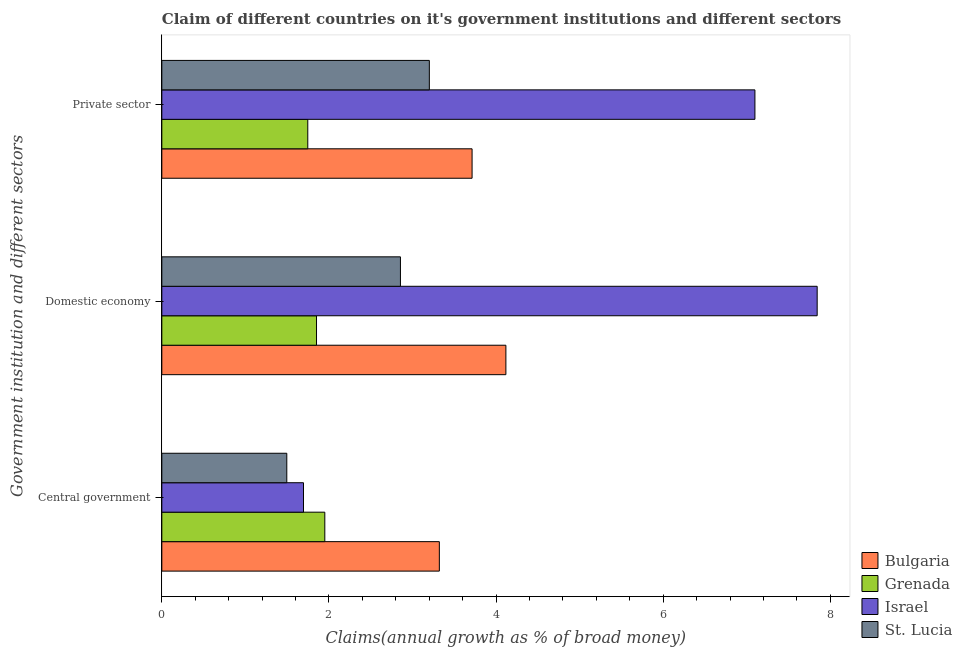How many groups of bars are there?
Give a very brief answer. 3. Are the number of bars per tick equal to the number of legend labels?
Your answer should be compact. Yes. Are the number of bars on each tick of the Y-axis equal?
Your answer should be compact. Yes. How many bars are there on the 2nd tick from the top?
Ensure brevity in your answer.  4. What is the label of the 2nd group of bars from the top?
Provide a short and direct response. Domestic economy. What is the percentage of claim on the central government in Grenada?
Your response must be concise. 1.95. Across all countries, what is the maximum percentage of claim on the domestic economy?
Keep it short and to the point. 7.84. Across all countries, what is the minimum percentage of claim on the central government?
Give a very brief answer. 1.5. In which country was the percentage of claim on the private sector maximum?
Give a very brief answer. Israel. In which country was the percentage of claim on the domestic economy minimum?
Give a very brief answer. Grenada. What is the total percentage of claim on the central government in the graph?
Provide a succinct answer. 8.46. What is the difference between the percentage of claim on the domestic economy in Grenada and that in Israel?
Offer a terse response. -5.99. What is the difference between the percentage of claim on the domestic economy in Bulgaria and the percentage of claim on the central government in Grenada?
Ensure brevity in your answer.  2.17. What is the average percentage of claim on the central government per country?
Provide a short and direct response. 2.12. What is the difference between the percentage of claim on the domestic economy and percentage of claim on the central government in Israel?
Make the answer very short. 6.15. In how many countries, is the percentage of claim on the private sector greater than 4.4 %?
Offer a very short reply. 1. What is the ratio of the percentage of claim on the private sector in Israel to that in Bulgaria?
Keep it short and to the point. 1.91. Is the difference between the percentage of claim on the domestic economy in Grenada and Bulgaria greater than the difference between the percentage of claim on the central government in Grenada and Bulgaria?
Give a very brief answer. No. What is the difference between the highest and the second highest percentage of claim on the private sector?
Your answer should be compact. 3.38. What is the difference between the highest and the lowest percentage of claim on the central government?
Offer a terse response. 1.83. In how many countries, is the percentage of claim on the domestic economy greater than the average percentage of claim on the domestic economy taken over all countries?
Give a very brief answer. 1. What does the 4th bar from the top in Private sector represents?
Keep it short and to the point. Bulgaria. How many bars are there?
Offer a very short reply. 12. Are all the bars in the graph horizontal?
Provide a succinct answer. Yes. What is the difference between two consecutive major ticks on the X-axis?
Make the answer very short. 2. Are the values on the major ticks of X-axis written in scientific E-notation?
Provide a short and direct response. No. How are the legend labels stacked?
Your answer should be compact. Vertical. What is the title of the graph?
Offer a terse response. Claim of different countries on it's government institutions and different sectors. Does "Russian Federation" appear as one of the legend labels in the graph?
Your response must be concise. No. What is the label or title of the X-axis?
Your response must be concise. Claims(annual growth as % of broad money). What is the label or title of the Y-axis?
Keep it short and to the point. Government institution and different sectors. What is the Claims(annual growth as % of broad money) in Bulgaria in Central government?
Offer a terse response. 3.32. What is the Claims(annual growth as % of broad money) in Grenada in Central government?
Keep it short and to the point. 1.95. What is the Claims(annual growth as % of broad money) in Israel in Central government?
Your answer should be very brief. 1.7. What is the Claims(annual growth as % of broad money) of St. Lucia in Central government?
Offer a terse response. 1.5. What is the Claims(annual growth as % of broad money) of Bulgaria in Domestic economy?
Provide a succinct answer. 4.12. What is the Claims(annual growth as % of broad money) of Grenada in Domestic economy?
Give a very brief answer. 1.85. What is the Claims(annual growth as % of broad money) in Israel in Domestic economy?
Provide a short and direct response. 7.84. What is the Claims(annual growth as % of broad money) in St. Lucia in Domestic economy?
Ensure brevity in your answer.  2.86. What is the Claims(annual growth as % of broad money) of Bulgaria in Private sector?
Your answer should be very brief. 3.71. What is the Claims(annual growth as % of broad money) in Grenada in Private sector?
Your answer should be compact. 1.75. What is the Claims(annual growth as % of broad money) of Israel in Private sector?
Your answer should be compact. 7.1. What is the Claims(annual growth as % of broad money) of St. Lucia in Private sector?
Provide a short and direct response. 3.2. Across all Government institution and different sectors, what is the maximum Claims(annual growth as % of broad money) of Bulgaria?
Ensure brevity in your answer.  4.12. Across all Government institution and different sectors, what is the maximum Claims(annual growth as % of broad money) of Grenada?
Ensure brevity in your answer.  1.95. Across all Government institution and different sectors, what is the maximum Claims(annual growth as % of broad money) in Israel?
Offer a terse response. 7.84. Across all Government institution and different sectors, what is the maximum Claims(annual growth as % of broad money) in St. Lucia?
Offer a very short reply. 3.2. Across all Government institution and different sectors, what is the minimum Claims(annual growth as % of broad money) in Bulgaria?
Offer a terse response. 3.32. Across all Government institution and different sectors, what is the minimum Claims(annual growth as % of broad money) of Grenada?
Your answer should be compact. 1.75. Across all Government institution and different sectors, what is the minimum Claims(annual growth as % of broad money) of Israel?
Your answer should be compact. 1.7. Across all Government institution and different sectors, what is the minimum Claims(annual growth as % of broad money) in St. Lucia?
Offer a very short reply. 1.5. What is the total Claims(annual growth as % of broad money) of Bulgaria in the graph?
Ensure brevity in your answer.  11.15. What is the total Claims(annual growth as % of broad money) in Grenada in the graph?
Provide a succinct answer. 5.55. What is the total Claims(annual growth as % of broad money) of Israel in the graph?
Keep it short and to the point. 16.63. What is the total Claims(annual growth as % of broad money) in St. Lucia in the graph?
Your answer should be very brief. 7.55. What is the difference between the Claims(annual growth as % of broad money) of Bulgaria in Central government and that in Domestic economy?
Provide a succinct answer. -0.8. What is the difference between the Claims(annual growth as % of broad money) in Grenada in Central government and that in Domestic economy?
Offer a very short reply. 0.1. What is the difference between the Claims(annual growth as % of broad money) of Israel in Central government and that in Domestic economy?
Make the answer very short. -6.15. What is the difference between the Claims(annual growth as % of broad money) in St. Lucia in Central government and that in Domestic economy?
Your response must be concise. -1.36. What is the difference between the Claims(annual growth as % of broad money) in Bulgaria in Central government and that in Private sector?
Your response must be concise. -0.39. What is the difference between the Claims(annual growth as % of broad money) in Grenada in Central government and that in Private sector?
Your answer should be compact. 0.2. What is the difference between the Claims(annual growth as % of broad money) of Israel in Central government and that in Private sector?
Keep it short and to the point. -5.4. What is the difference between the Claims(annual growth as % of broad money) in St. Lucia in Central government and that in Private sector?
Offer a terse response. -1.71. What is the difference between the Claims(annual growth as % of broad money) in Bulgaria in Domestic economy and that in Private sector?
Provide a succinct answer. 0.4. What is the difference between the Claims(annual growth as % of broad money) in Grenada in Domestic economy and that in Private sector?
Your answer should be very brief. 0.1. What is the difference between the Claims(annual growth as % of broad money) in Israel in Domestic economy and that in Private sector?
Provide a succinct answer. 0.74. What is the difference between the Claims(annual growth as % of broad money) in St. Lucia in Domestic economy and that in Private sector?
Keep it short and to the point. -0.35. What is the difference between the Claims(annual growth as % of broad money) in Bulgaria in Central government and the Claims(annual growth as % of broad money) in Grenada in Domestic economy?
Ensure brevity in your answer.  1.47. What is the difference between the Claims(annual growth as % of broad money) in Bulgaria in Central government and the Claims(annual growth as % of broad money) in Israel in Domestic economy?
Offer a very short reply. -4.52. What is the difference between the Claims(annual growth as % of broad money) of Bulgaria in Central government and the Claims(annual growth as % of broad money) of St. Lucia in Domestic economy?
Your answer should be compact. 0.47. What is the difference between the Claims(annual growth as % of broad money) of Grenada in Central government and the Claims(annual growth as % of broad money) of Israel in Domestic economy?
Your answer should be compact. -5.89. What is the difference between the Claims(annual growth as % of broad money) of Grenada in Central government and the Claims(annual growth as % of broad money) of St. Lucia in Domestic economy?
Ensure brevity in your answer.  -0.9. What is the difference between the Claims(annual growth as % of broad money) of Israel in Central government and the Claims(annual growth as % of broad money) of St. Lucia in Domestic economy?
Ensure brevity in your answer.  -1.16. What is the difference between the Claims(annual growth as % of broad money) of Bulgaria in Central government and the Claims(annual growth as % of broad money) of Grenada in Private sector?
Your answer should be compact. 1.57. What is the difference between the Claims(annual growth as % of broad money) of Bulgaria in Central government and the Claims(annual growth as % of broad money) of Israel in Private sector?
Provide a short and direct response. -3.78. What is the difference between the Claims(annual growth as % of broad money) in Bulgaria in Central government and the Claims(annual growth as % of broad money) in St. Lucia in Private sector?
Offer a very short reply. 0.12. What is the difference between the Claims(annual growth as % of broad money) in Grenada in Central government and the Claims(annual growth as % of broad money) in Israel in Private sector?
Offer a very short reply. -5.15. What is the difference between the Claims(annual growth as % of broad money) in Grenada in Central government and the Claims(annual growth as % of broad money) in St. Lucia in Private sector?
Make the answer very short. -1.25. What is the difference between the Claims(annual growth as % of broad money) of Israel in Central government and the Claims(annual growth as % of broad money) of St. Lucia in Private sector?
Provide a succinct answer. -1.51. What is the difference between the Claims(annual growth as % of broad money) in Bulgaria in Domestic economy and the Claims(annual growth as % of broad money) in Grenada in Private sector?
Provide a short and direct response. 2.37. What is the difference between the Claims(annual growth as % of broad money) in Bulgaria in Domestic economy and the Claims(annual growth as % of broad money) in Israel in Private sector?
Your answer should be very brief. -2.98. What is the difference between the Claims(annual growth as % of broad money) in Bulgaria in Domestic economy and the Claims(annual growth as % of broad money) in St. Lucia in Private sector?
Your response must be concise. 0.92. What is the difference between the Claims(annual growth as % of broad money) in Grenada in Domestic economy and the Claims(annual growth as % of broad money) in Israel in Private sector?
Your answer should be compact. -5.25. What is the difference between the Claims(annual growth as % of broad money) of Grenada in Domestic economy and the Claims(annual growth as % of broad money) of St. Lucia in Private sector?
Offer a very short reply. -1.35. What is the difference between the Claims(annual growth as % of broad money) of Israel in Domestic economy and the Claims(annual growth as % of broad money) of St. Lucia in Private sector?
Your answer should be compact. 4.64. What is the average Claims(annual growth as % of broad money) in Bulgaria per Government institution and different sectors?
Offer a terse response. 3.72. What is the average Claims(annual growth as % of broad money) of Grenada per Government institution and different sectors?
Ensure brevity in your answer.  1.85. What is the average Claims(annual growth as % of broad money) of Israel per Government institution and different sectors?
Your answer should be very brief. 5.54. What is the average Claims(annual growth as % of broad money) of St. Lucia per Government institution and different sectors?
Offer a very short reply. 2.52. What is the difference between the Claims(annual growth as % of broad money) in Bulgaria and Claims(annual growth as % of broad money) in Grenada in Central government?
Give a very brief answer. 1.37. What is the difference between the Claims(annual growth as % of broad money) of Bulgaria and Claims(annual growth as % of broad money) of Israel in Central government?
Ensure brevity in your answer.  1.63. What is the difference between the Claims(annual growth as % of broad money) of Bulgaria and Claims(annual growth as % of broad money) of St. Lucia in Central government?
Keep it short and to the point. 1.83. What is the difference between the Claims(annual growth as % of broad money) of Grenada and Claims(annual growth as % of broad money) of Israel in Central government?
Provide a succinct answer. 0.26. What is the difference between the Claims(annual growth as % of broad money) in Grenada and Claims(annual growth as % of broad money) in St. Lucia in Central government?
Your answer should be very brief. 0.46. What is the difference between the Claims(annual growth as % of broad money) in Bulgaria and Claims(annual growth as % of broad money) in Grenada in Domestic economy?
Offer a very short reply. 2.27. What is the difference between the Claims(annual growth as % of broad money) of Bulgaria and Claims(annual growth as % of broad money) of Israel in Domestic economy?
Your answer should be compact. -3.73. What is the difference between the Claims(annual growth as % of broad money) in Bulgaria and Claims(annual growth as % of broad money) in St. Lucia in Domestic economy?
Your response must be concise. 1.26. What is the difference between the Claims(annual growth as % of broad money) in Grenada and Claims(annual growth as % of broad money) in Israel in Domestic economy?
Your answer should be compact. -5.99. What is the difference between the Claims(annual growth as % of broad money) of Grenada and Claims(annual growth as % of broad money) of St. Lucia in Domestic economy?
Your answer should be compact. -1. What is the difference between the Claims(annual growth as % of broad money) of Israel and Claims(annual growth as % of broad money) of St. Lucia in Domestic economy?
Keep it short and to the point. 4.99. What is the difference between the Claims(annual growth as % of broad money) of Bulgaria and Claims(annual growth as % of broad money) of Grenada in Private sector?
Your answer should be very brief. 1.97. What is the difference between the Claims(annual growth as % of broad money) of Bulgaria and Claims(annual growth as % of broad money) of Israel in Private sector?
Provide a succinct answer. -3.38. What is the difference between the Claims(annual growth as % of broad money) in Bulgaria and Claims(annual growth as % of broad money) in St. Lucia in Private sector?
Give a very brief answer. 0.51. What is the difference between the Claims(annual growth as % of broad money) in Grenada and Claims(annual growth as % of broad money) in Israel in Private sector?
Your answer should be very brief. -5.35. What is the difference between the Claims(annual growth as % of broad money) of Grenada and Claims(annual growth as % of broad money) of St. Lucia in Private sector?
Your answer should be compact. -1.45. What is the difference between the Claims(annual growth as % of broad money) in Israel and Claims(annual growth as % of broad money) in St. Lucia in Private sector?
Your answer should be very brief. 3.9. What is the ratio of the Claims(annual growth as % of broad money) in Bulgaria in Central government to that in Domestic economy?
Your answer should be compact. 0.81. What is the ratio of the Claims(annual growth as % of broad money) of Grenada in Central government to that in Domestic economy?
Your response must be concise. 1.05. What is the ratio of the Claims(annual growth as % of broad money) of Israel in Central government to that in Domestic economy?
Your response must be concise. 0.22. What is the ratio of the Claims(annual growth as % of broad money) in St. Lucia in Central government to that in Domestic economy?
Provide a succinct answer. 0.52. What is the ratio of the Claims(annual growth as % of broad money) in Bulgaria in Central government to that in Private sector?
Your response must be concise. 0.89. What is the ratio of the Claims(annual growth as % of broad money) in Grenada in Central government to that in Private sector?
Make the answer very short. 1.12. What is the ratio of the Claims(annual growth as % of broad money) of Israel in Central government to that in Private sector?
Ensure brevity in your answer.  0.24. What is the ratio of the Claims(annual growth as % of broad money) of St. Lucia in Central government to that in Private sector?
Your answer should be very brief. 0.47. What is the ratio of the Claims(annual growth as % of broad money) of Bulgaria in Domestic economy to that in Private sector?
Offer a terse response. 1.11. What is the ratio of the Claims(annual growth as % of broad money) in Grenada in Domestic economy to that in Private sector?
Provide a succinct answer. 1.06. What is the ratio of the Claims(annual growth as % of broad money) of Israel in Domestic economy to that in Private sector?
Provide a short and direct response. 1.1. What is the ratio of the Claims(annual growth as % of broad money) in St. Lucia in Domestic economy to that in Private sector?
Provide a succinct answer. 0.89. What is the difference between the highest and the second highest Claims(annual growth as % of broad money) in Bulgaria?
Your answer should be compact. 0.4. What is the difference between the highest and the second highest Claims(annual growth as % of broad money) of Grenada?
Offer a terse response. 0.1. What is the difference between the highest and the second highest Claims(annual growth as % of broad money) of Israel?
Give a very brief answer. 0.74. What is the difference between the highest and the second highest Claims(annual growth as % of broad money) of St. Lucia?
Your response must be concise. 0.35. What is the difference between the highest and the lowest Claims(annual growth as % of broad money) in Bulgaria?
Make the answer very short. 0.8. What is the difference between the highest and the lowest Claims(annual growth as % of broad money) of Grenada?
Offer a very short reply. 0.2. What is the difference between the highest and the lowest Claims(annual growth as % of broad money) of Israel?
Offer a terse response. 6.15. What is the difference between the highest and the lowest Claims(annual growth as % of broad money) of St. Lucia?
Your answer should be compact. 1.71. 